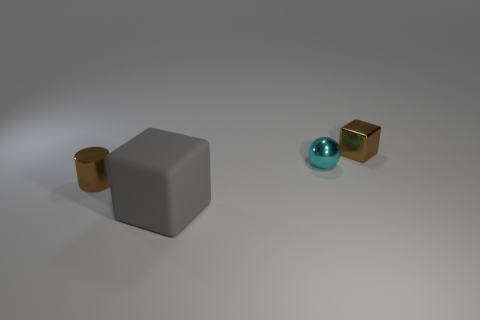Add 3 small yellow metallic objects. How many objects exist? 7 Subtract all balls. How many objects are left? 3 Subtract 0 blue cubes. How many objects are left? 4 Subtract all small blocks. Subtract all tiny things. How many objects are left? 0 Add 1 big gray matte blocks. How many big gray matte blocks are left? 2 Add 3 big purple rubber things. How many big purple rubber things exist? 3 